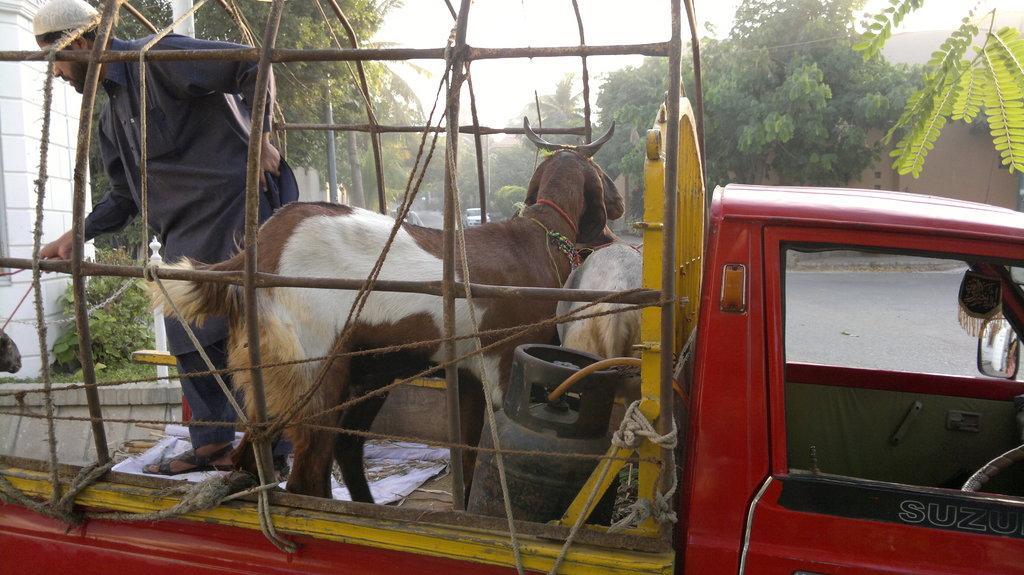In one or two sentences, can you explain what this image depicts? In this picture I can see there is a small truck and there are two goats, there is a man standing and holding a rope, it is tied to a goat. There is a road and there are trees on both sides of the road and there are few poles and the sky is clear. 